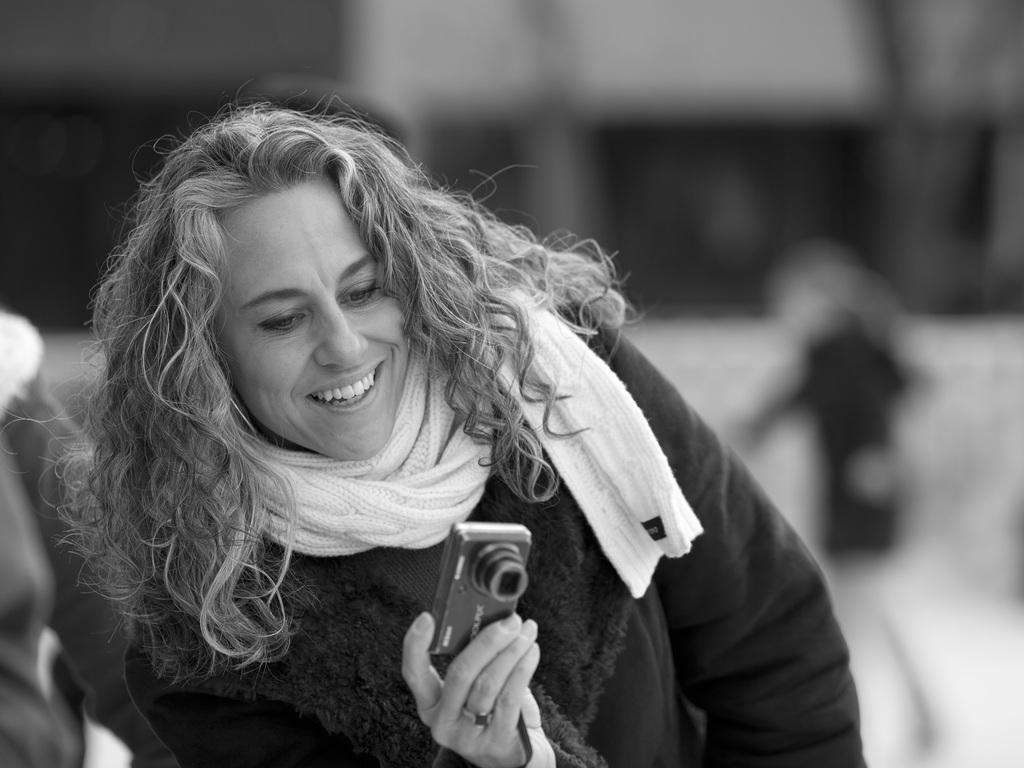Could you give a brief overview of what you see in this image? The women wearing the black dress is holding a camera in her right hand. 